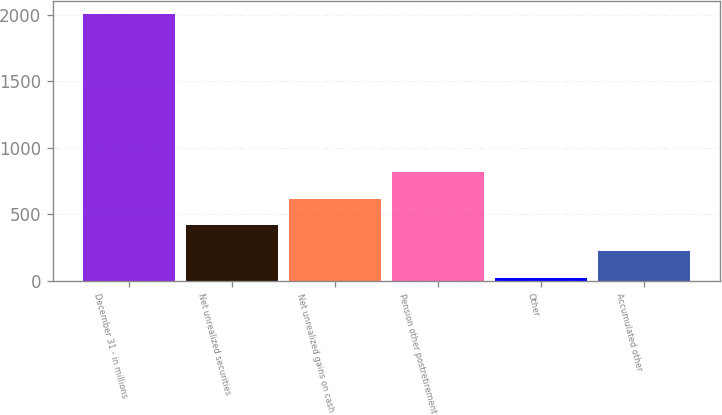Convert chart to OTSL. <chart><loc_0><loc_0><loc_500><loc_500><bar_chart><fcel>December 31 - in millions<fcel>Net unrealized securities<fcel>Net unrealized gains on cash<fcel>Pension other postretirement<fcel>Other<fcel>Accumulated other<nl><fcel>2007<fcel>419<fcel>617.5<fcel>816<fcel>22<fcel>220.5<nl></chart> 